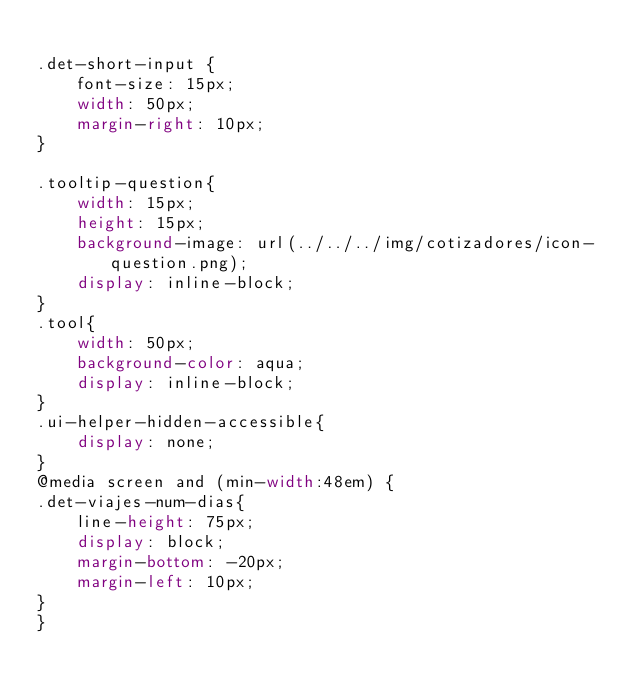Convert code to text. <code><loc_0><loc_0><loc_500><loc_500><_CSS_>
.det-short-input {
    font-size: 15px;
    width: 50px;
    margin-right: 10px;
}

.tooltip-question{
    width: 15px;
    height: 15px;
    background-image: url(../../../img/cotizadores/icon-question.png);
    display: inline-block;
}
.tool{
    width: 50px;
    background-color: aqua;
    display: inline-block;
}
.ui-helper-hidden-accessible{
    display: none;
}
@media screen and (min-width:48em) {
.det-viajes-num-dias{
    line-height: 75px;
    display: block;
    margin-bottom: -20px;
    margin-left: 10px;
}
}</code> 